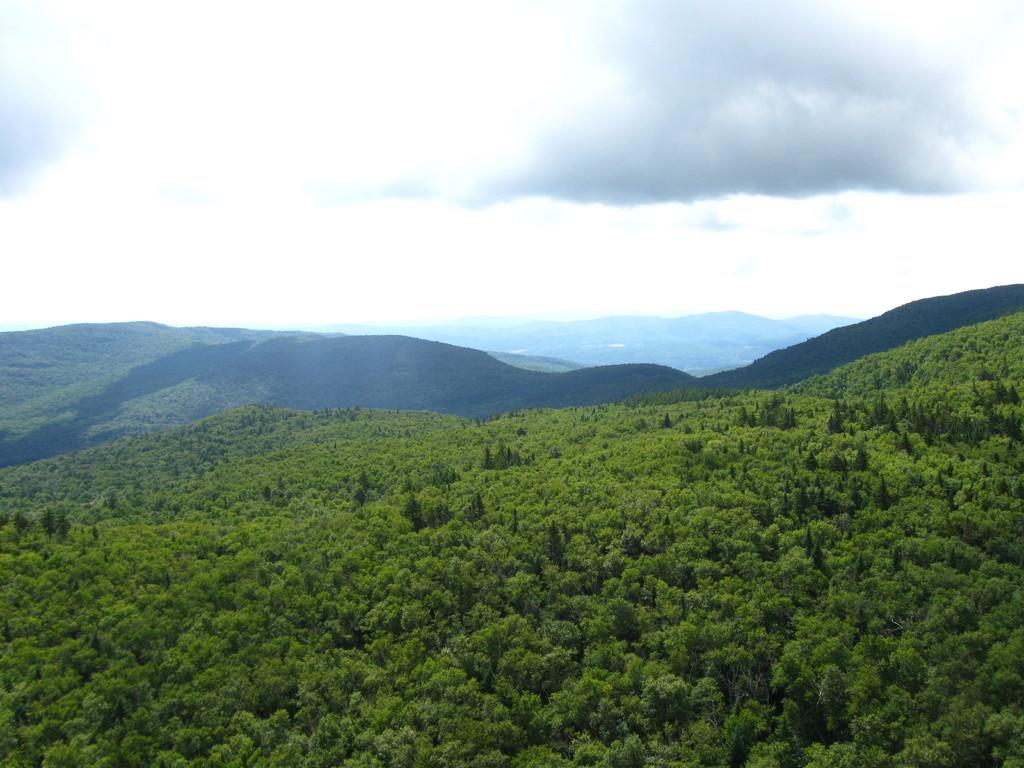What type of vegetation can be seen in the image? There are trees in the image. What type of geographical feature is present in the image? There are hills in the image. What type of leather can be seen on the rose in the image? There is no leather or rose present in the image; it only features trees and hills. 